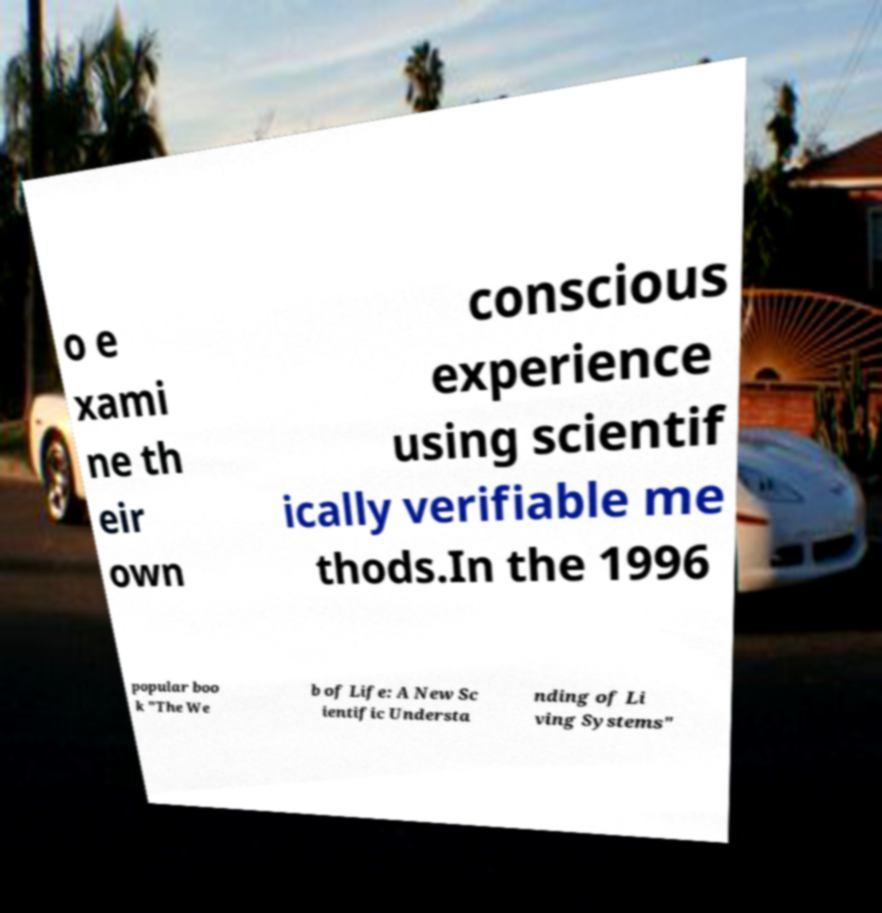What messages or text are displayed in this image? I need them in a readable, typed format. o e xami ne th eir own conscious experience using scientif ically verifiable me thods.In the 1996 popular boo k "The We b of Life: A New Sc ientific Understa nding of Li ving Systems" 